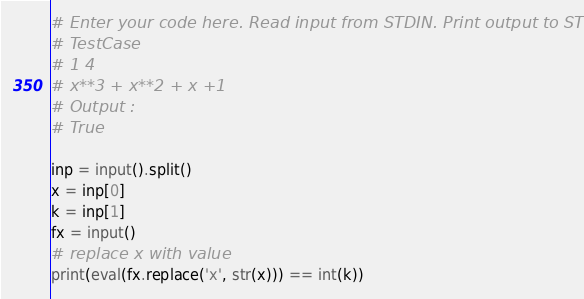Convert code to text. <code><loc_0><loc_0><loc_500><loc_500><_Python_># Enter your code here. Read input from STDIN. Print output to STDOUT
# TestCase
# 1 4
# x**3 + x**2 + x +1 
# Output :
# True

inp = input().split()
x = inp[0]
k = inp[1]
fx = input()
# replace x with value
print(eval(fx.replace('x', str(x))) == int(k))
</code> 